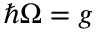<formula> <loc_0><loc_0><loc_500><loc_500>\hbar { \Omega } = g</formula> 